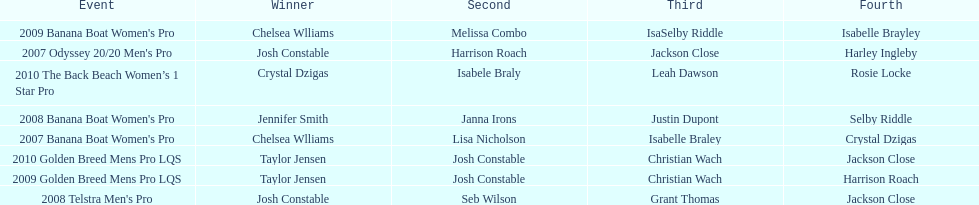Name each of the years that taylor jensen was winner. 2009, 2010. 